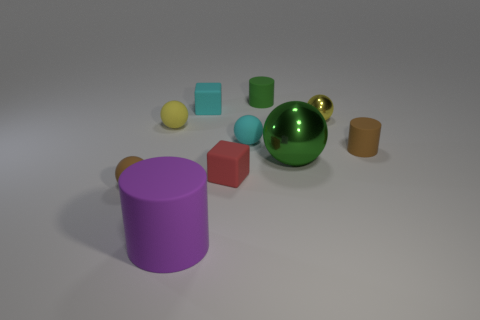Subtract all brown matte cylinders. How many cylinders are left? 2 Subtract all brown cubes. How many yellow balls are left? 2 Subtract 1 cubes. How many cubes are left? 1 Subtract all green spheres. How many spheres are left? 4 Subtract all red blocks. Subtract all cyan cylinders. How many blocks are left? 1 Subtract all red spheres. Subtract all cyan rubber things. How many objects are left? 8 Add 4 tiny green rubber cylinders. How many tiny green rubber cylinders are left? 5 Add 10 tiny purple cylinders. How many tiny purple cylinders exist? 10 Subtract 0 purple spheres. How many objects are left? 10 Subtract all cylinders. How many objects are left? 7 